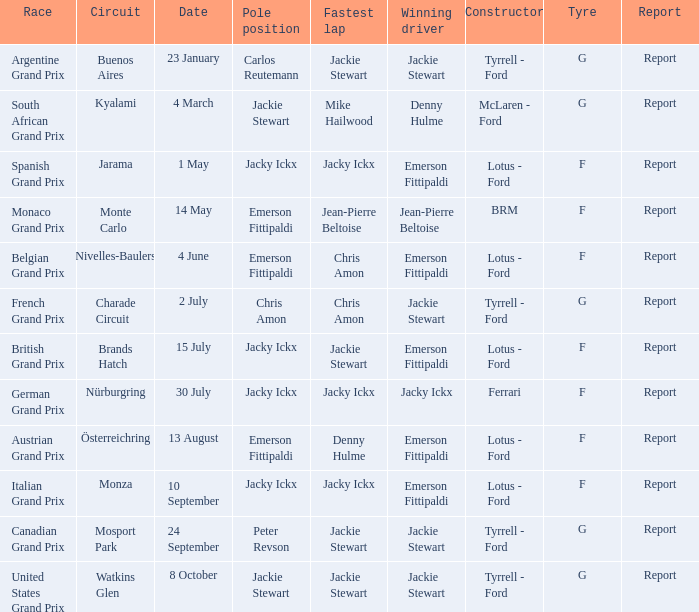At which circuit was the british grand prix held? Brands Hatch. 